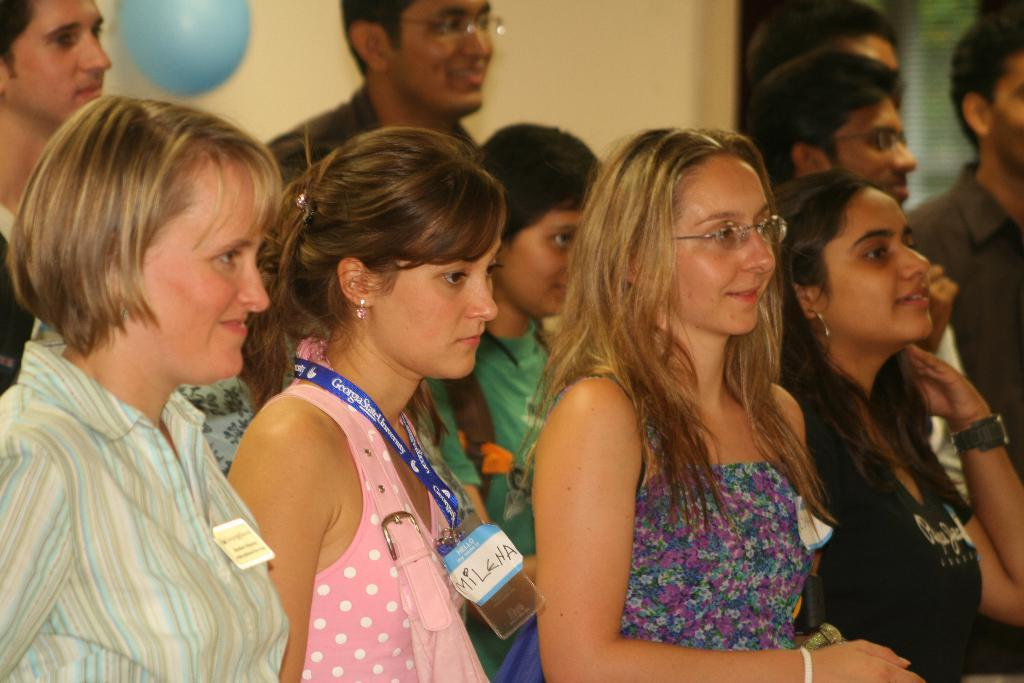How many people are in the group in the image? There is a group of people in the image, but the exact number is not specified. What is the facial expression of some people in the group? Some people in the group are smiling. What can be seen in the background of the image? There is a wall, a glass object, and a balloon in the background of the image. What decorative items are present in the image? Stickers are present in the image. What type of label is visible in the image? There is a tag in the image. What type of plough is being used by the people in the image? There is no plough present in the image; it features a group of people, a wall, a glass object, a balloon, stickers, and a tag. How many trees can be seen in the image? There are no trees visible in the image. 